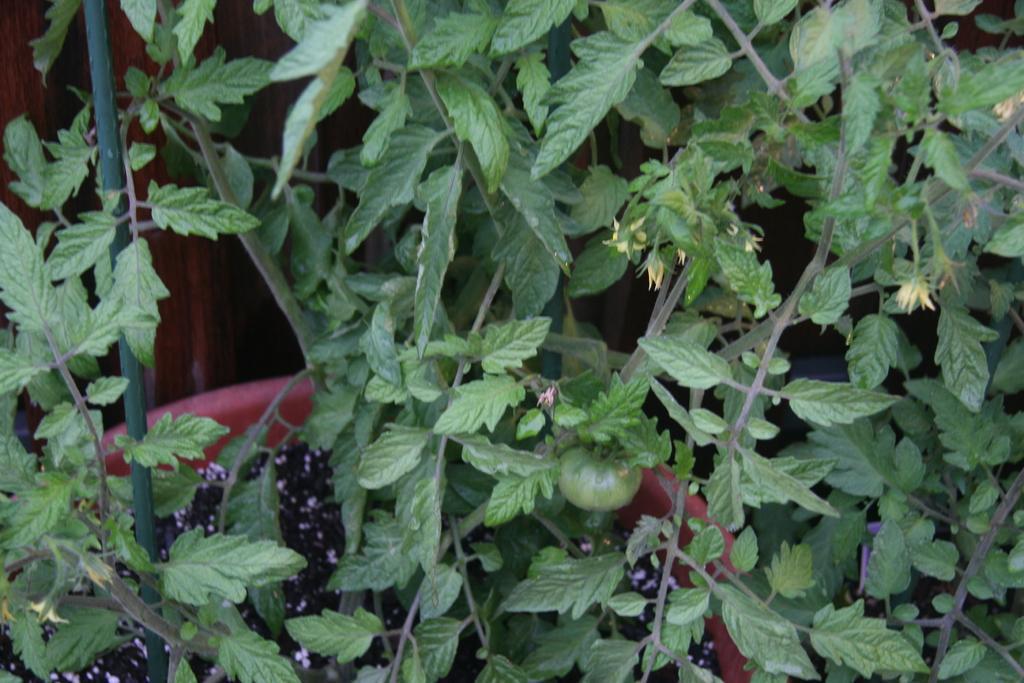Please provide a concise description of this image. In this image there are leaves, flowers, fruits and a pot. 